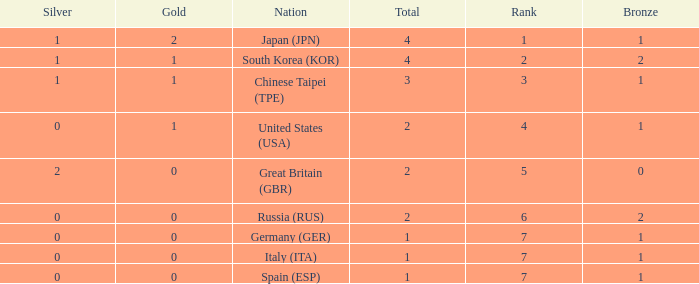How many total medals does a country with more than 1 silver medals have? 2.0. 